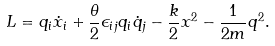<formula> <loc_0><loc_0><loc_500><loc_500>L = q _ { i } \dot { x } _ { i } + \frac { \theta } { 2 } \epsilon _ { i j } q _ { i } \dot { q } _ { j } - \frac { k } { 2 } x ^ { 2 } - \frac { 1 } { 2 m } q ^ { 2 } .</formula> 